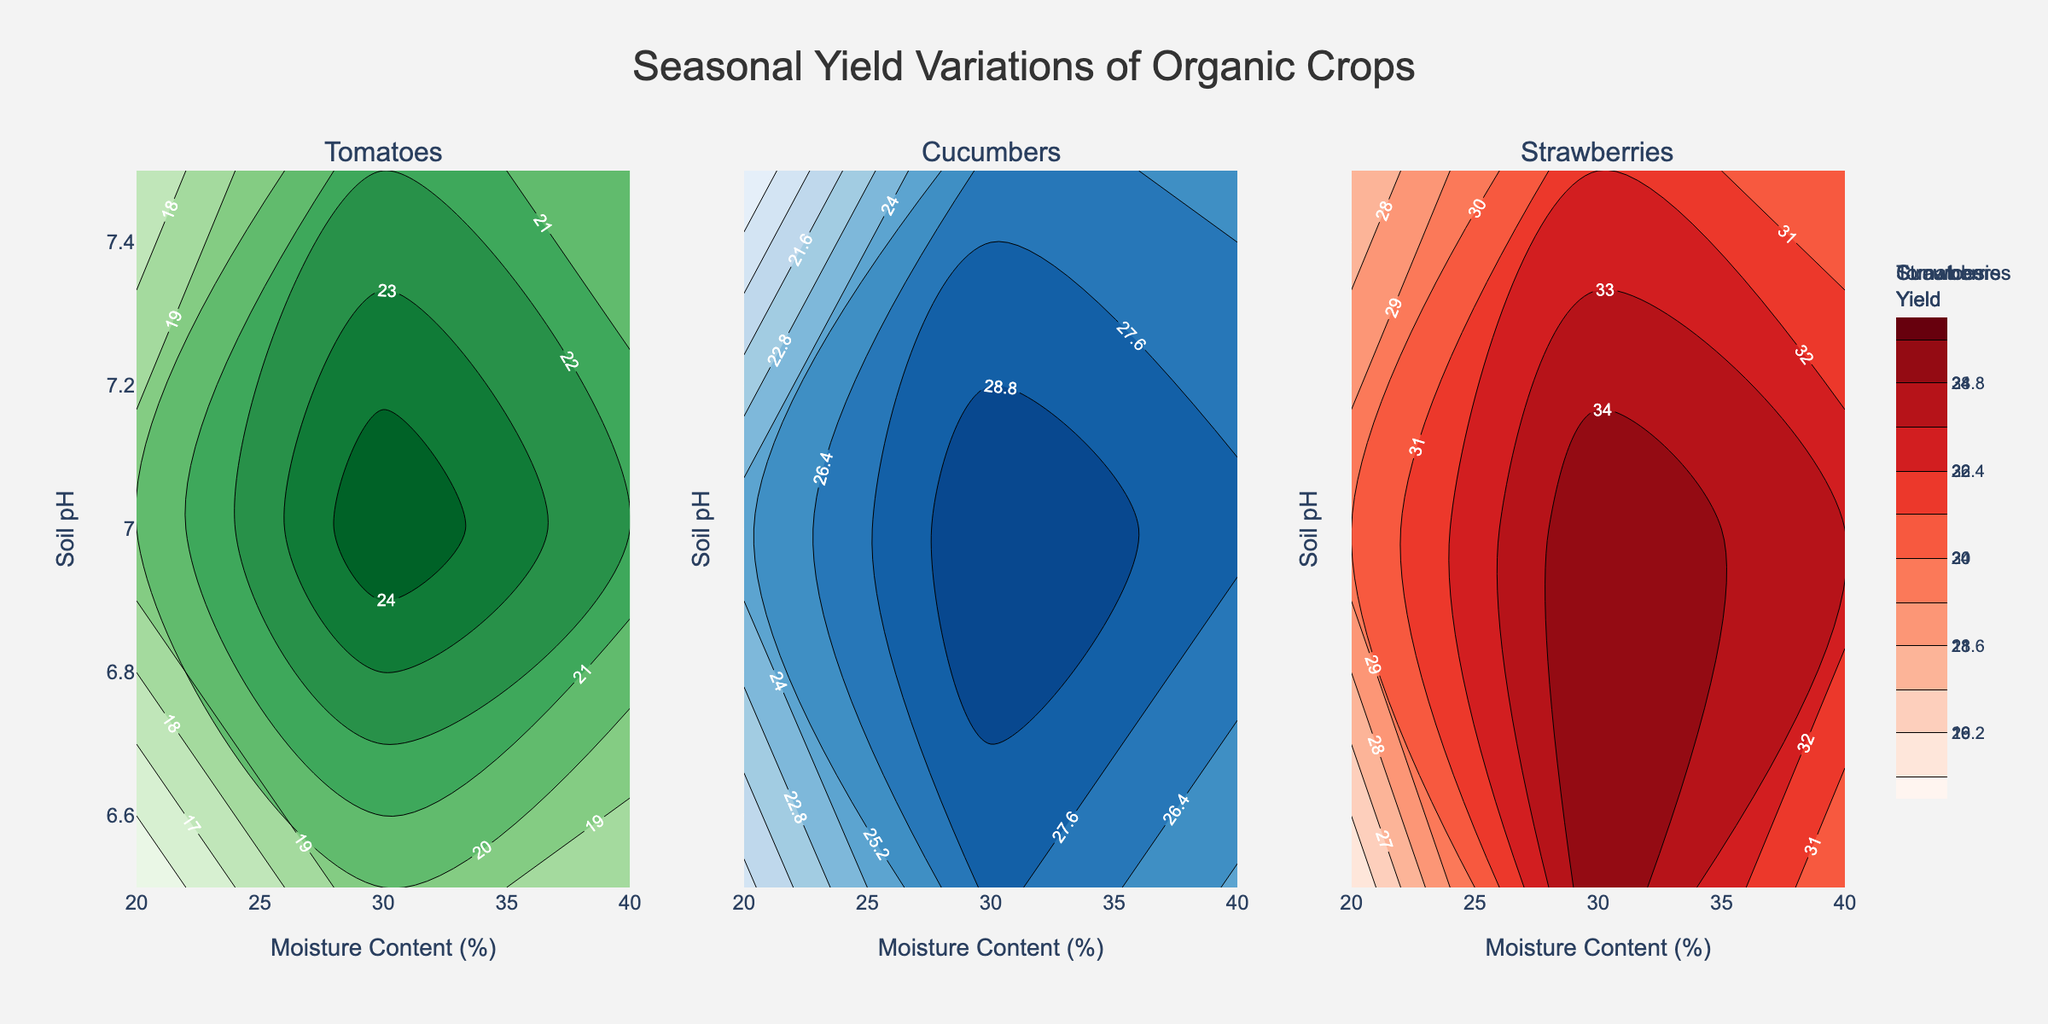What is the title of the plot? The title of the plot is generally found at the top center of the figure. Here it reads "Seasonal Yield Variations of Organic Crops".
Answer: Seasonal Yield Variations of Organic Crops Which axis shows the Soil pH? The y-axis usually represents one of the variables, and in this figure, it is labeled as "Soil pH".
Answer: y-axis What is the color used for the contour plot of Cucumbers? Each subplot has a distinctive color associated with it. The contour plot for Cucumbers uses shades of blue.
Answer: Blue Which crop has the highest yield at Soil pH 7.0 and Moisture Content 30? At Soil pH 7.0 and Moisture Content 30, you can check the contour values for all three crops. Strawberries have the highest yield on this combination.
Answer: Strawberries What is the optimal soil pH for maximizing tomato yield based on the figure? To determine the optimal soil pH for tomatoes, compare the contour lines for different soil pH values and find where the highest yield is obtained. The highest yield is at Soil pH 7.0.
Answer: 7.0 Which crop shows the highest yield variation with changes in Moisture Content, keeping Soil pH constant? Observe the contour spreads or changes for each crop as the Moisture Content varies, keeping Soil pH fixed. Cucumbers exhibit the highest yield variation with Moisture Content changes.
Answer: Cucumbers What is the yield of cucumbers at Soil pH 6.5 and Moisture Content 30? Locate Soil pH 6.5 on the y-axis and Moisture Content 30 on the x-axis. The contour plot for cucumbers shows a yield value at this combination, which is 28.
Answer: 28 If the Soil pH is 7.5, which crop has the most uniform yield response across the different moisture levels? At Soil pH 7.5, check the contour plots to compare the consistency of the yield across different Moisture Content levels. Strawberries show the most uniform yield response.
Answer: Strawberries What is the approximate yield difference of Tomatoes between Moisture Content 20 and 40 at Soil pH 6.5? Identify the yield values for Tomatoes at Moisture Content 20 and 40 for Soil pH 6.5 from the contour plot. Subtract 15 from 18, resulting in a yield difference of 3.
Answer: 3 How does the yield of cucumbers change with an increase in Soil pH from 6.5 to 7.5 at Moisture Content 30? Check the yield values of cucumbers at Moisture Content 30 for Soil pH 6.5 and 7.5. The yield increases from 28 to 27, indicating a slight decrease.
Answer: Slight decrease 